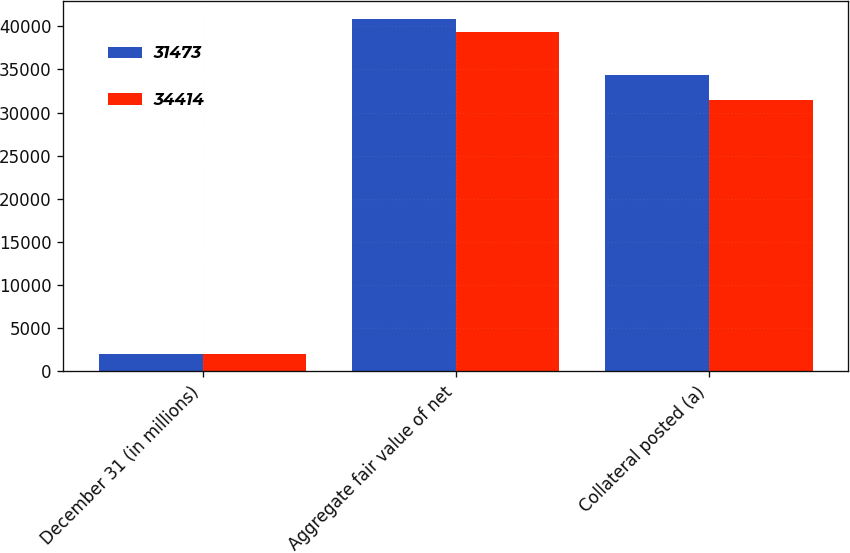<chart> <loc_0><loc_0><loc_500><loc_500><stacked_bar_chart><ecel><fcel>December 31 (in millions)<fcel>Aggregate fair value of net<fcel>Collateral posted (a)<nl><fcel>31473<fcel>2012<fcel>40844<fcel>34414<nl><fcel>34414<fcel>2011<fcel>39316<fcel>31473<nl></chart> 